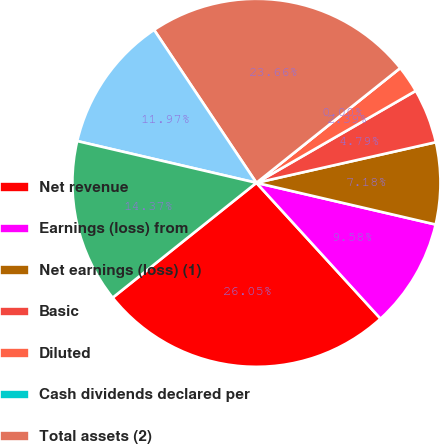Convert chart to OTSL. <chart><loc_0><loc_0><loc_500><loc_500><pie_chart><fcel>Net revenue<fcel>Earnings (loss) from<fcel>Net earnings (loss) (1)<fcel>Basic<fcel>Diluted<fcel>Cash dividends declared per<fcel>Total assets (2)<fcel>Long-term debt<fcel>Total debt (3)<nl><fcel>26.05%<fcel>9.58%<fcel>7.18%<fcel>4.79%<fcel>2.39%<fcel>0.0%<fcel>23.66%<fcel>11.97%<fcel>14.37%<nl></chart> 